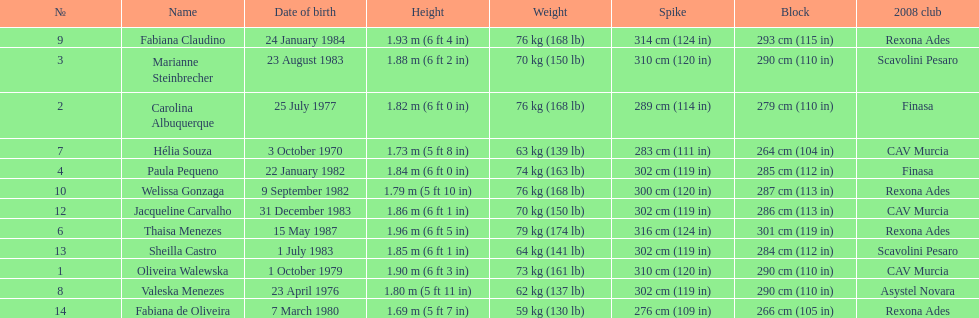Oliveira walewska has the same block as how many other players? 2. 